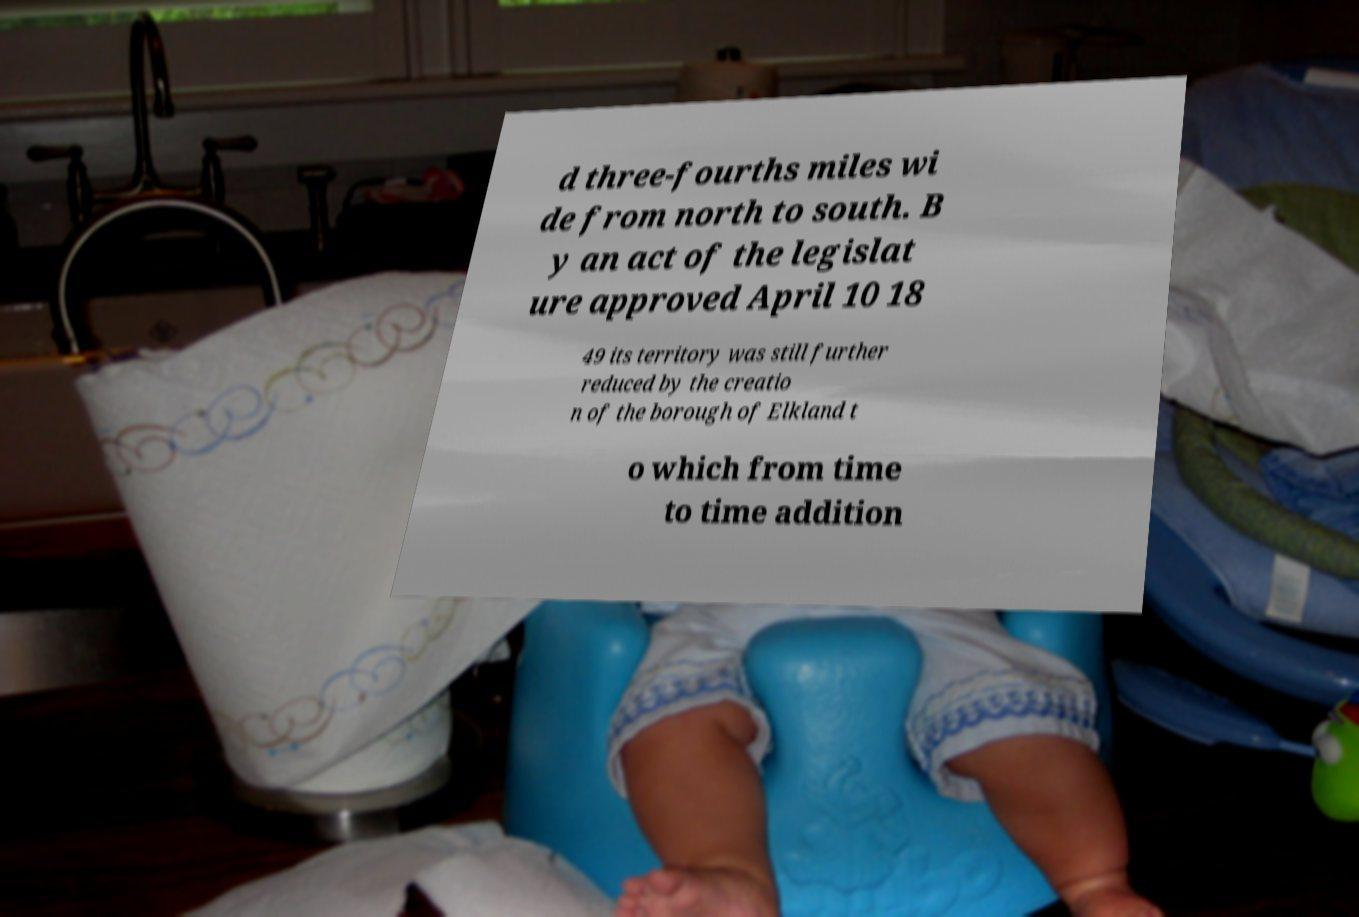What messages or text are displayed in this image? I need them in a readable, typed format. d three-fourths miles wi de from north to south. B y an act of the legislat ure approved April 10 18 49 its territory was still further reduced by the creatio n of the borough of Elkland t o which from time to time addition 